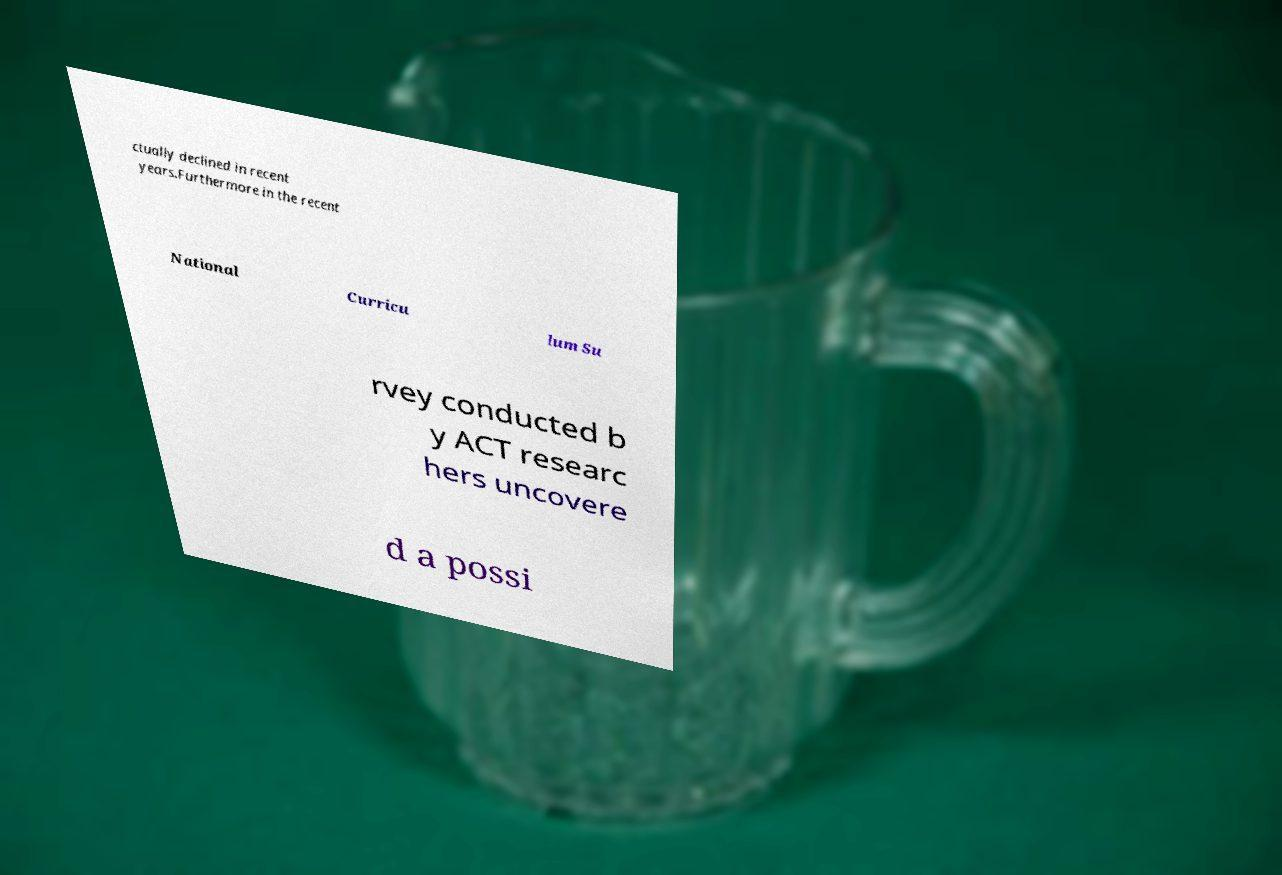Could you extract and type out the text from this image? ctually declined in recent years.Furthermore in the recent National Curricu lum Su rvey conducted b y ACT researc hers uncovere d a possi 